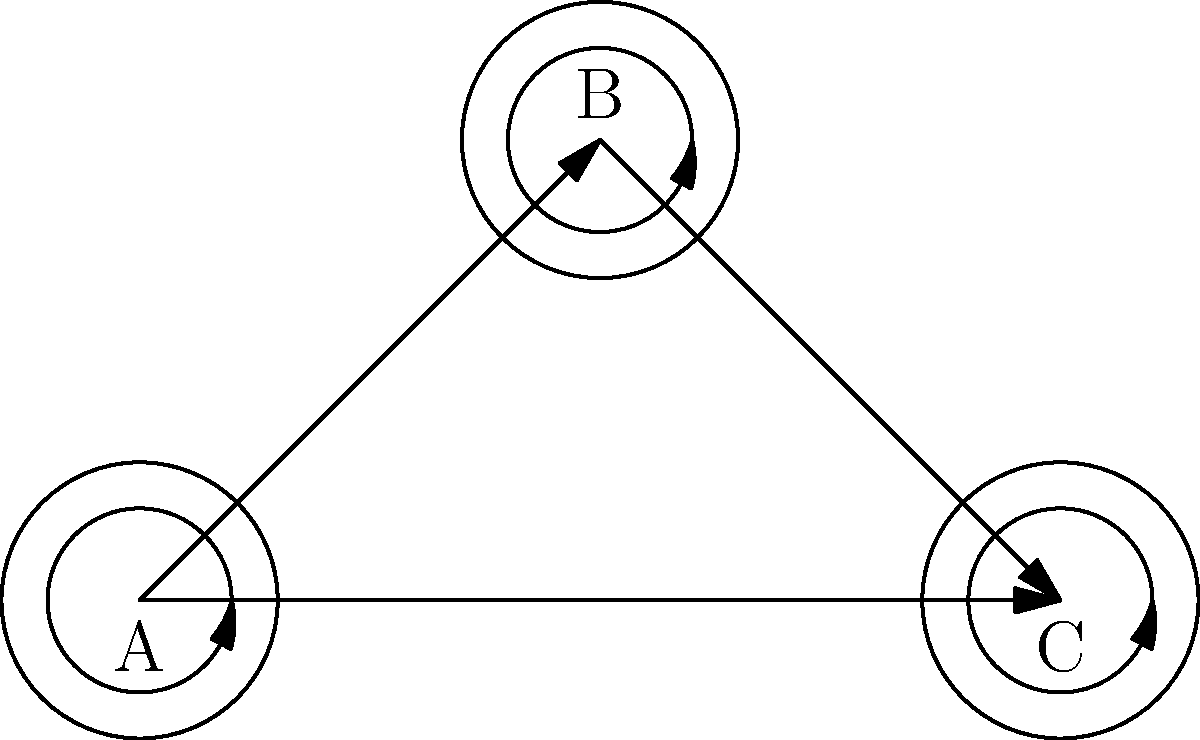Consider the topological representation of synaptic connections between three brain regions A, B, and C. What is the maximum number of distinct closed walks of length 3 that can be formed in this network? To solve this problem, we need to follow these steps:

1. Understand the concept of a closed walk:
   - A closed walk is a sequence of connections that starts and ends at the same node.
   - The length of a walk is the number of connections used.

2. Identify all possible closed walks of length 3:
   - We need to consider walks that use 3 connections and return to the starting point.

3. Enumerate the possibilities:
   a) Self-loops: Each node has a self-connection, so we can form closed walks of length 3 by repeating the self-loop 3 times.
      - A → A → A → A
      - B → B → B → B
      - C → C → C → C

   b) Two-node walks: We can go back and forth between two connected nodes.
      - A → B → A → A
      - A → C → A → A
      - B → A → B → B
      - B → C → B → B
      - C → A → C → C
      - C → B → C → C

   c) Three-node walks: We can traverse all three nodes in a cycle.
      - A → B → C → A
      - A → C → B → A

4. Count the total number of distinct closed walks:
   - Self-loops: 3
   - Two-node walks: 6
   - Three-node walks: 2
   - Total: 3 + 6 + 2 = 11

Therefore, the maximum number of distinct closed walks of length 3 in this network is 11.
Answer: 11 